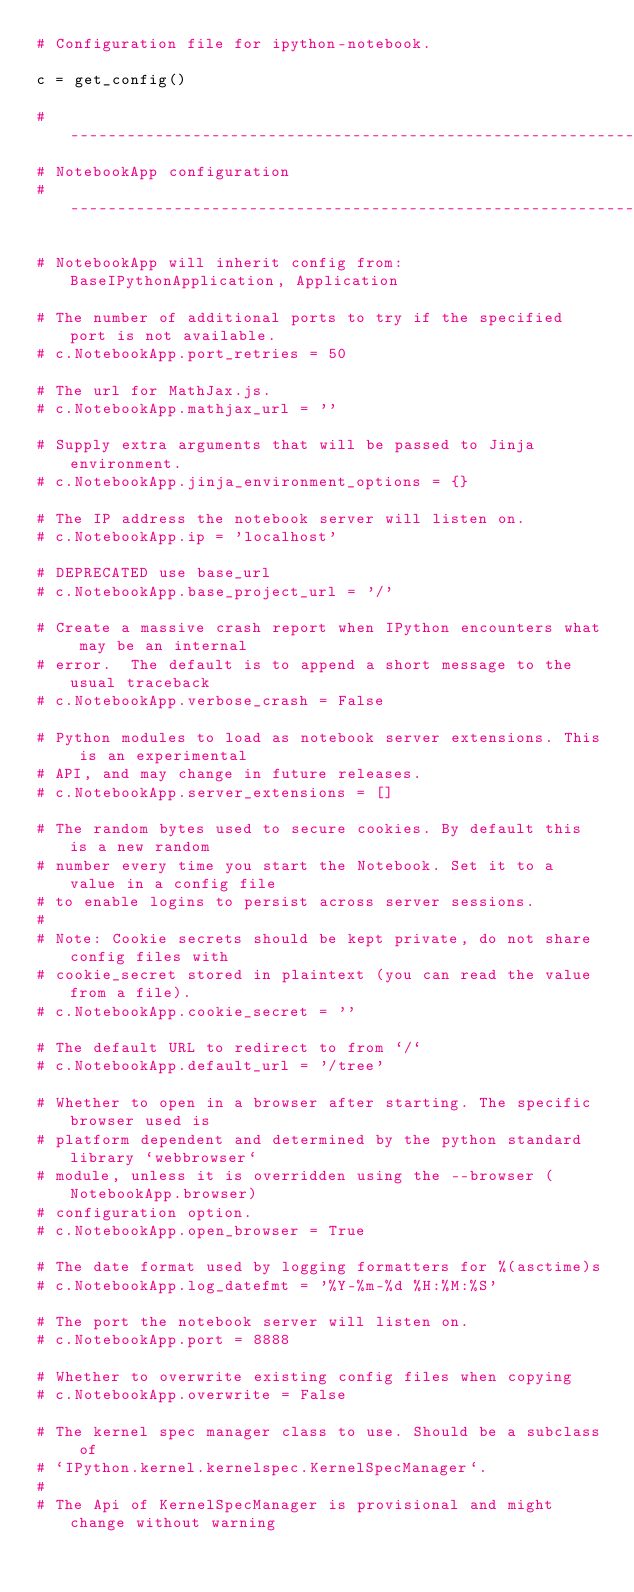Convert code to text. <code><loc_0><loc_0><loc_500><loc_500><_Python_># Configuration file for ipython-notebook.

c = get_config()

#------------------------------------------------------------------------------
# NotebookApp configuration
#------------------------------------------------------------------------------

# NotebookApp will inherit config from: BaseIPythonApplication, Application

# The number of additional ports to try if the specified port is not available.
# c.NotebookApp.port_retries = 50

# The url for MathJax.js.
# c.NotebookApp.mathjax_url = ''

# Supply extra arguments that will be passed to Jinja environment.
# c.NotebookApp.jinja_environment_options = {}

# The IP address the notebook server will listen on.
# c.NotebookApp.ip = 'localhost'

# DEPRECATED use base_url
# c.NotebookApp.base_project_url = '/'

# Create a massive crash report when IPython encounters what may be an internal
# error.  The default is to append a short message to the usual traceback
# c.NotebookApp.verbose_crash = False

# Python modules to load as notebook server extensions. This is an experimental
# API, and may change in future releases.
# c.NotebookApp.server_extensions = []

# The random bytes used to secure cookies. By default this is a new random
# number every time you start the Notebook. Set it to a value in a config file
# to enable logins to persist across server sessions.
# 
# Note: Cookie secrets should be kept private, do not share config files with
# cookie_secret stored in plaintext (you can read the value from a file).
# c.NotebookApp.cookie_secret = ''

# The default URL to redirect to from `/`
# c.NotebookApp.default_url = '/tree'

# Whether to open in a browser after starting. The specific browser used is
# platform dependent and determined by the python standard library `webbrowser`
# module, unless it is overridden using the --browser (NotebookApp.browser)
# configuration option.
# c.NotebookApp.open_browser = True

# The date format used by logging formatters for %(asctime)s
# c.NotebookApp.log_datefmt = '%Y-%m-%d %H:%M:%S'

# The port the notebook server will listen on.
# c.NotebookApp.port = 8888

# Whether to overwrite existing config files when copying
# c.NotebookApp.overwrite = False

# The kernel spec manager class to use. Should be a subclass of
# `IPython.kernel.kernelspec.KernelSpecManager`.
# 
# The Api of KernelSpecManager is provisional and might change without warning</code> 